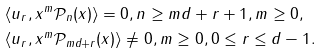<formula> <loc_0><loc_0><loc_500><loc_500>& \langle u _ { r } , x ^ { m } \mathcal { P } _ { n } ( x ) \rangle = 0 , n \geq m d + r + 1 , m \geq 0 , \\ & \langle u _ { r } , x ^ { m } \mathcal { P } _ { m d + r } ( x ) \rangle \neq 0 , m \geq 0 , 0 \leq r \leq d - 1 .</formula> 